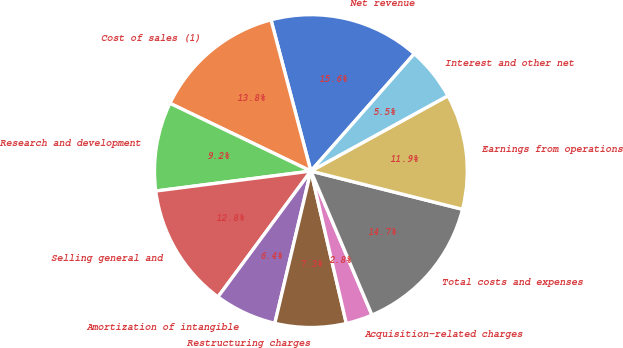<chart> <loc_0><loc_0><loc_500><loc_500><pie_chart><fcel>Net revenue<fcel>Cost of sales (1)<fcel>Research and development<fcel>Selling general and<fcel>Amortization of intangible<fcel>Restructuring charges<fcel>Acquisition-related charges<fcel>Total costs and expenses<fcel>Earnings from operations<fcel>Interest and other net<nl><fcel>15.6%<fcel>13.76%<fcel>9.17%<fcel>12.84%<fcel>6.42%<fcel>7.34%<fcel>2.75%<fcel>14.68%<fcel>11.93%<fcel>5.5%<nl></chart> 